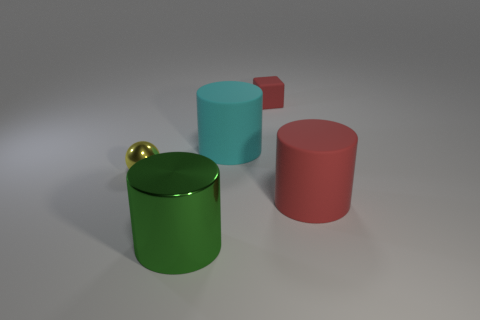Can you describe the textures of the objects in the image? The objects appear to have uniformly smooth textures, reflecting their CGI nature. No surface imperfections or variations are visible, which contributes to their simplistic, stylized aesthetic. 